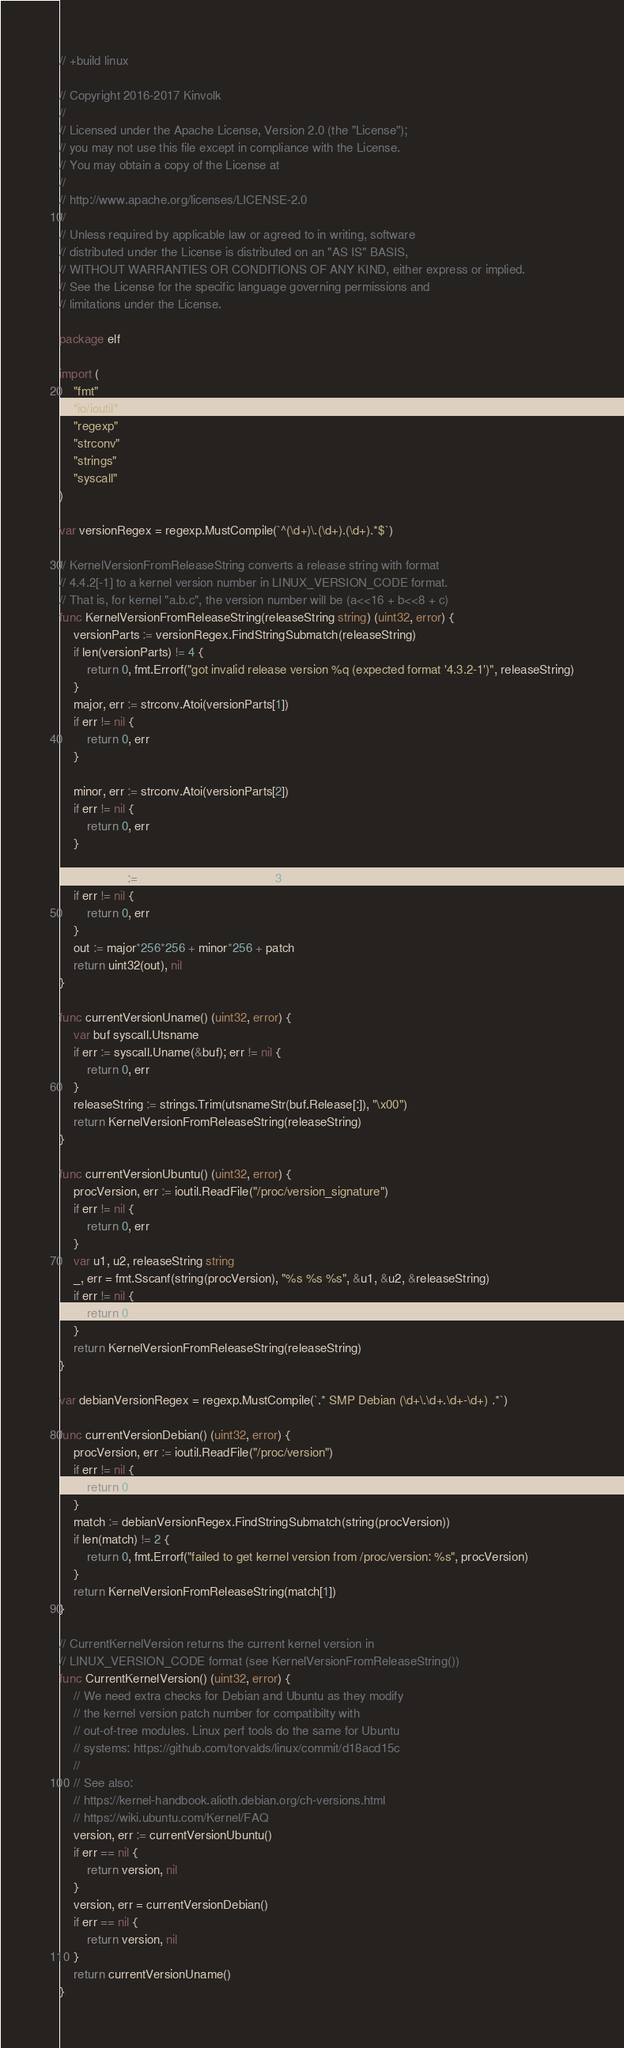<code> <loc_0><loc_0><loc_500><loc_500><_Go_>// +build linux

// Copyright 2016-2017 Kinvolk
//
// Licensed under the Apache License, Version 2.0 (the "License");
// you may not use this file except in compliance with the License.
// You may obtain a copy of the License at
//
// http://www.apache.org/licenses/LICENSE-2.0
//
// Unless required by applicable law or agreed to in writing, software
// distributed under the License is distributed on an "AS IS" BASIS,
// WITHOUT WARRANTIES OR CONDITIONS OF ANY KIND, either express or implied.
// See the License for the specific language governing permissions and
// limitations under the License.

package elf

import (
	"fmt"
	"io/ioutil"
	"regexp"
	"strconv"
	"strings"
	"syscall"
)

var versionRegex = regexp.MustCompile(`^(\d+)\.(\d+).(\d+).*$`)

// KernelVersionFromReleaseString converts a release string with format
// 4.4.2[-1] to a kernel version number in LINUX_VERSION_CODE format.
// That is, for kernel "a.b.c", the version number will be (a<<16 + b<<8 + c)
func KernelVersionFromReleaseString(releaseString string) (uint32, error) {
	versionParts := versionRegex.FindStringSubmatch(releaseString)
	if len(versionParts) != 4 {
		return 0, fmt.Errorf("got invalid release version %q (expected format '4.3.2-1')", releaseString)
	}
	major, err := strconv.Atoi(versionParts[1])
	if err != nil {
		return 0, err
	}

	minor, err := strconv.Atoi(versionParts[2])
	if err != nil {
		return 0, err
	}

	patch, err := strconv.Atoi(versionParts[3])
	if err != nil {
		return 0, err
	}
	out := major*256*256 + minor*256 + patch
	return uint32(out), nil
}

func currentVersionUname() (uint32, error) {
	var buf syscall.Utsname
	if err := syscall.Uname(&buf); err != nil {
		return 0, err
	}
	releaseString := strings.Trim(utsnameStr(buf.Release[:]), "\x00")
	return KernelVersionFromReleaseString(releaseString)
}

func currentVersionUbuntu() (uint32, error) {
	procVersion, err := ioutil.ReadFile("/proc/version_signature")
	if err != nil {
		return 0, err
	}
	var u1, u2, releaseString string
	_, err = fmt.Sscanf(string(procVersion), "%s %s %s", &u1, &u2, &releaseString)
	if err != nil {
		return 0, err
	}
	return KernelVersionFromReleaseString(releaseString)
}

var debianVersionRegex = regexp.MustCompile(`.* SMP Debian (\d+\.\d+.\d+-\d+) .*`)

func currentVersionDebian() (uint32, error) {
	procVersion, err := ioutil.ReadFile("/proc/version")
	if err != nil {
		return 0, err
	}
	match := debianVersionRegex.FindStringSubmatch(string(procVersion))
	if len(match) != 2 {
		return 0, fmt.Errorf("failed to get kernel version from /proc/version: %s", procVersion)
	}
	return KernelVersionFromReleaseString(match[1])
}

// CurrentKernelVersion returns the current kernel version in
// LINUX_VERSION_CODE format (see KernelVersionFromReleaseString())
func CurrentKernelVersion() (uint32, error) {
	// We need extra checks for Debian and Ubuntu as they modify
	// the kernel version patch number for compatibilty with
	// out-of-tree modules. Linux perf tools do the same for Ubuntu
	// systems: https://github.com/torvalds/linux/commit/d18acd15c
	//
	// See also:
	// https://kernel-handbook.alioth.debian.org/ch-versions.html
	// https://wiki.ubuntu.com/Kernel/FAQ
	version, err := currentVersionUbuntu()
	if err == nil {
		return version, nil
	}
	version, err = currentVersionDebian()
	if err == nil {
		return version, nil
	}
	return currentVersionUname()
}
</code> 